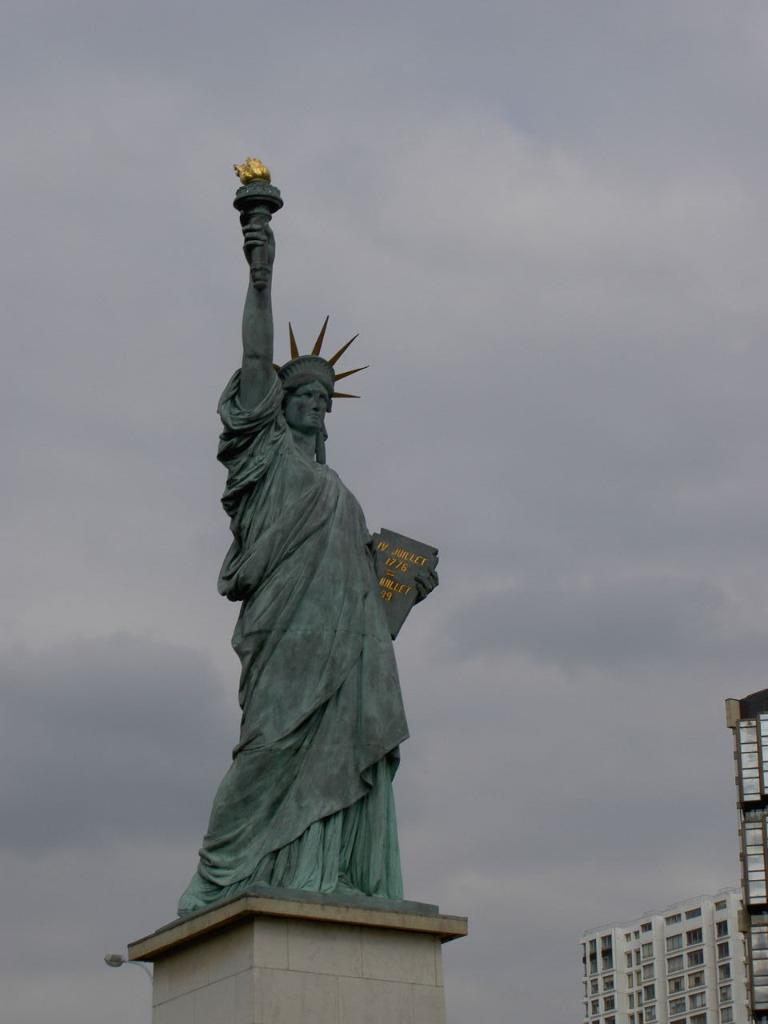What famous landmark is present in the image? The image contains the Statue of Liberty. What is the color of the Statue of Liberty in the image? The Statue of Liberty is in grey color. What can be seen on the right side of the image? There are buildings on the right side of the image. What is visible in the background of the image? There is a sky visible in the background of the image. What is the condition of the sky in the image? There are clouds in the sky. What type of square can be seen on the Statue of Liberty's head in the image? There is no square present on the Statue of Liberty's head in the image. What is causing the Statue of Liberty to burn in the image? The Statue of Liberty is not on fire or burning in the image. 